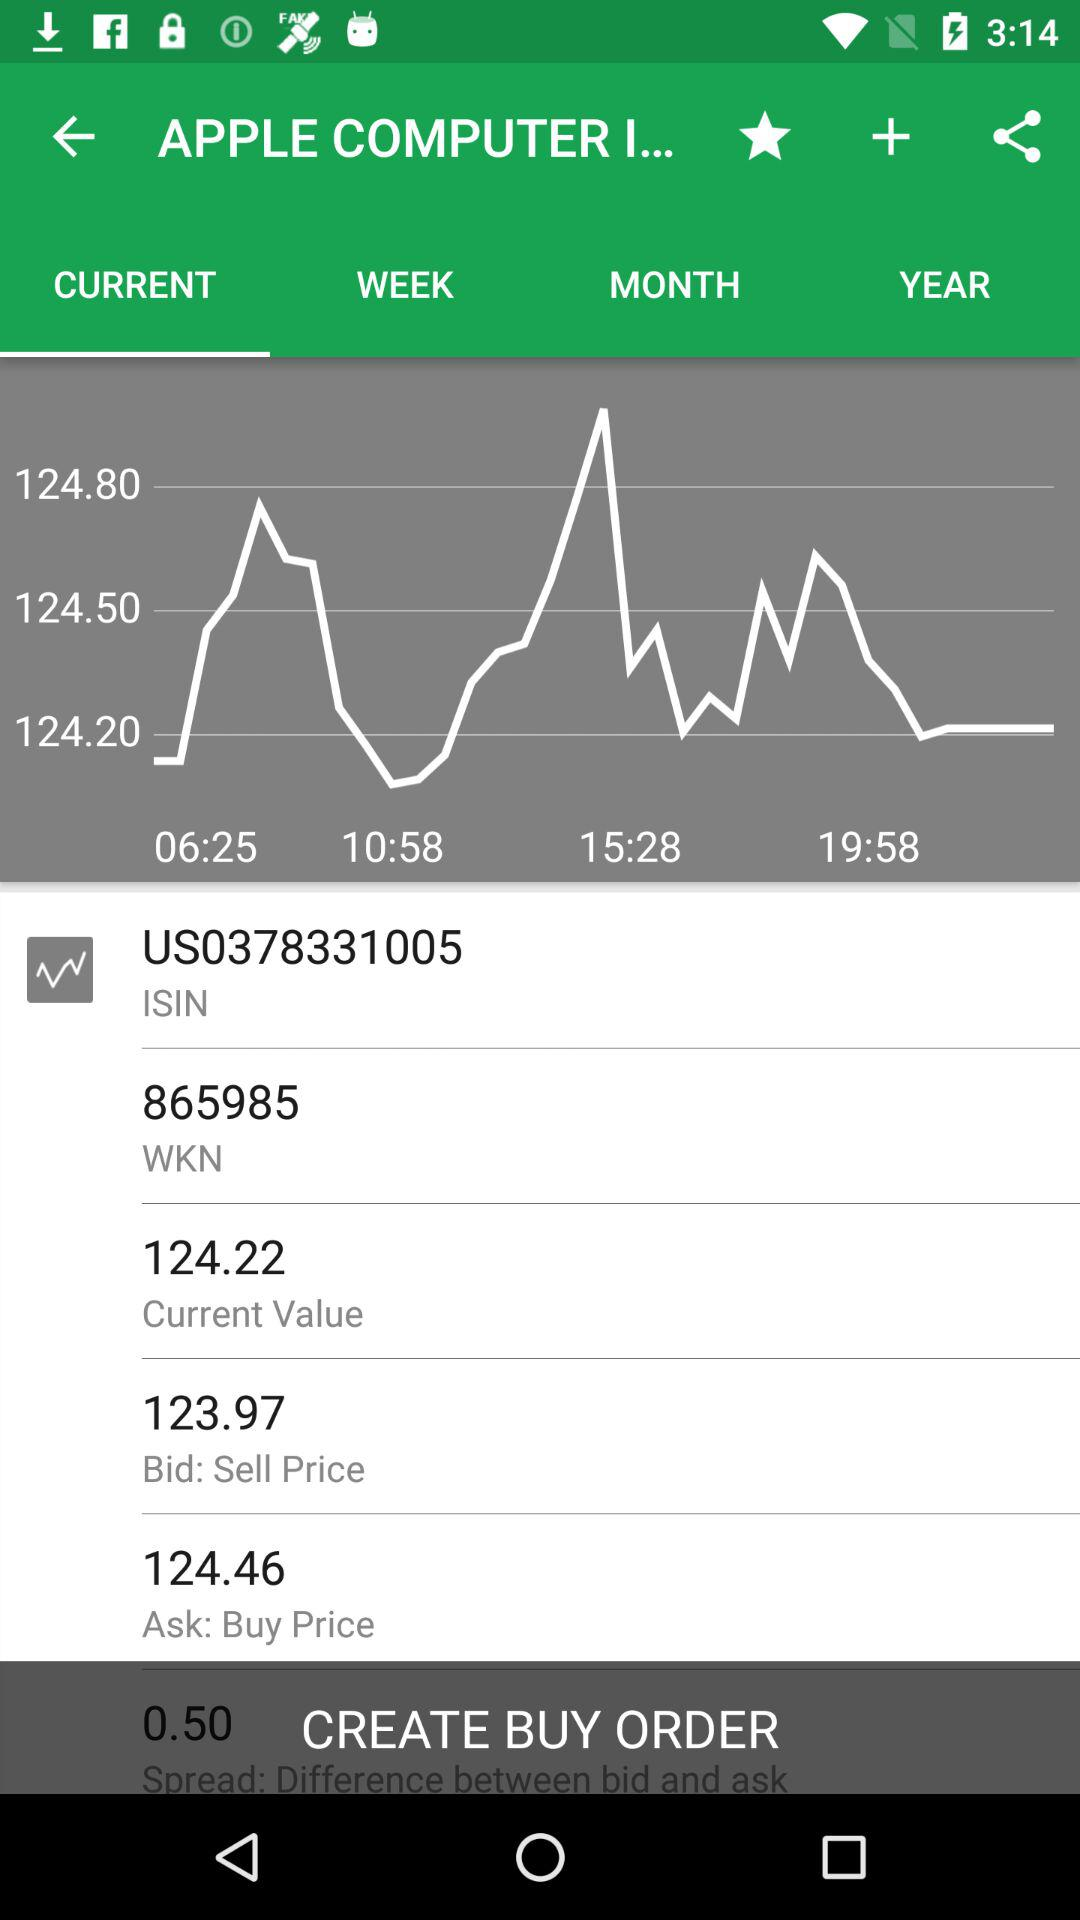What is the current value of the stock?
Answer the question using a single word or phrase. 124.22 